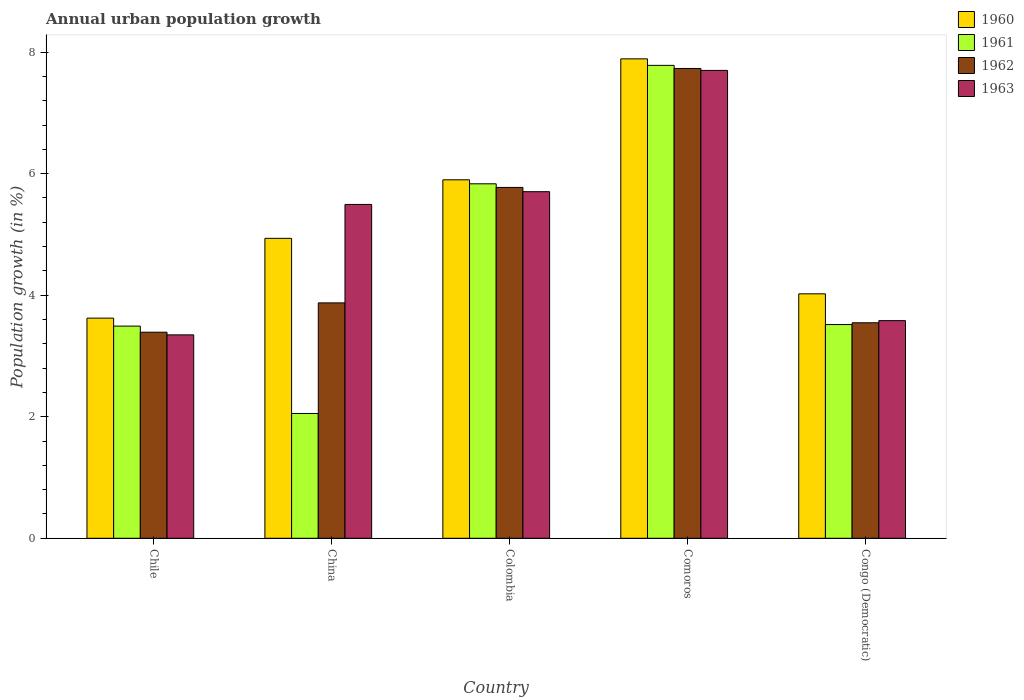How many different coloured bars are there?
Make the answer very short. 4. How many groups of bars are there?
Give a very brief answer. 5. How many bars are there on the 4th tick from the left?
Make the answer very short. 4. What is the label of the 3rd group of bars from the left?
Keep it short and to the point. Colombia. What is the percentage of urban population growth in 1963 in Comoros?
Provide a succinct answer. 7.7. Across all countries, what is the maximum percentage of urban population growth in 1963?
Keep it short and to the point. 7.7. Across all countries, what is the minimum percentage of urban population growth in 1962?
Your response must be concise. 3.39. In which country was the percentage of urban population growth in 1963 maximum?
Give a very brief answer. Comoros. In which country was the percentage of urban population growth in 1963 minimum?
Your answer should be compact. Chile. What is the total percentage of urban population growth in 1960 in the graph?
Keep it short and to the point. 26.37. What is the difference between the percentage of urban population growth in 1962 in Chile and that in China?
Keep it short and to the point. -0.48. What is the difference between the percentage of urban population growth in 1960 in Colombia and the percentage of urban population growth in 1963 in Comoros?
Your answer should be compact. -1.8. What is the average percentage of urban population growth in 1963 per country?
Offer a terse response. 5.17. What is the difference between the percentage of urban population growth of/in 1961 and percentage of urban population growth of/in 1962 in China?
Your answer should be compact. -1.82. In how many countries, is the percentage of urban population growth in 1962 greater than 1.2000000000000002 %?
Provide a succinct answer. 5. What is the ratio of the percentage of urban population growth in 1960 in China to that in Comoros?
Your answer should be very brief. 0.63. What is the difference between the highest and the second highest percentage of urban population growth in 1962?
Your answer should be compact. -1.9. What is the difference between the highest and the lowest percentage of urban population growth in 1963?
Offer a terse response. 4.35. Is it the case that in every country, the sum of the percentage of urban population growth in 1960 and percentage of urban population growth in 1963 is greater than the sum of percentage of urban population growth in 1961 and percentage of urban population growth in 1962?
Give a very brief answer. No. What does the 1st bar from the left in Colombia represents?
Make the answer very short. 1960. Is it the case that in every country, the sum of the percentage of urban population growth in 1960 and percentage of urban population growth in 1962 is greater than the percentage of urban population growth in 1961?
Make the answer very short. Yes. Are all the bars in the graph horizontal?
Ensure brevity in your answer.  No. How many countries are there in the graph?
Your answer should be compact. 5. Does the graph contain any zero values?
Offer a terse response. No. How are the legend labels stacked?
Make the answer very short. Vertical. What is the title of the graph?
Provide a succinct answer. Annual urban population growth. What is the label or title of the Y-axis?
Your answer should be very brief. Population growth (in %). What is the Population growth (in %) in 1960 in Chile?
Your answer should be very brief. 3.62. What is the Population growth (in %) in 1961 in Chile?
Provide a short and direct response. 3.49. What is the Population growth (in %) of 1962 in Chile?
Make the answer very short. 3.39. What is the Population growth (in %) in 1963 in Chile?
Your answer should be compact. 3.35. What is the Population growth (in %) in 1960 in China?
Your answer should be compact. 4.94. What is the Population growth (in %) of 1961 in China?
Your answer should be very brief. 2.05. What is the Population growth (in %) of 1962 in China?
Your response must be concise. 3.87. What is the Population growth (in %) of 1963 in China?
Your response must be concise. 5.49. What is the Population growth (in %) in 1960 in Colombia?
Your answer should be very brief. 5.9. What is the Population growth (in %) in 1961 in Colombia?
Make the answer very short. 5.83. What is the Population growth (in %) in 1962 in Colombia?
Provide a short and direct response. 5.77. What is the Population growth (in %) in 1963 in Colombia?
Provide a succinct answer. 5.7. What is the Population growth (in %) of 1960 in Comoros?
Provide a short and direct response. 7.89. What is the Population growth (in %) in 1961 in Comoros?
Keep it short and to the point. 7.78. What is the Population growth (in %) of 1962 in Comoros?
Make the answer very short. 7.73. What is the Population growth (in %) in 1963 in Comoros?
Offer a terse response. 7.7. What is the Population growth (in %) of 1960 in Congo (Democratic)?
Ensure brevity in your answer.  4.02. What is the Population growth (in %) in 1961 in Congo (Democratic)?
Make the answer very short. 3.52. What is the Population growth (in %) in 1962 in Congo (Democratic)?
Your response must be concise. 3.55. What is the Population growth (in %) in 1963 in Congo (Democratic)?
Make the answer very short. 3.58. Across all countries, what is the maximum Population growth (in %) in 1960?
Make the answer very short. 7.89. Across all countries, what is the maximum Population growth (in %) of 1961?
Your answer should be very brief. 7.78. Across all countries, what is the maximum Population growth (in %) of 1962?
Provide a short and direct response. 7.73. Across all countries, what is the maximum Population growth (in %) of 1963?
Your answer should be very brief. 7.7. Across all countries, what is the minimum Population growth (in %) in 1960?
Your response must be concise. 3.62. Across all countries, what is the minimum Population growth (in %) of 1961?
Provide a succinct answer. 2.05. Across all countries, what is the minimum Population growth (in %) in 1962?
Provide a succinct answer. 3.39. Across all countries, what is the minimum Population growth (in %) in 1963?
Make the answer very short. 3.35. What is the total Population growth (in %) in 1960 in the graph?
Provide a succinct answer. 26.37. What is the total Population growth (in %) of 1961 in the graph?
Give a very brief answer. 22.68. What is the total Population growth (in %) in 1962 in the graph?
Offer a terse response. 24.32. What is the total Population growth (in %) in 1963 in the graph?
Offer a very short reply. 25.82. What is the difference between the Population growth (in %) in 1960 in Chile and that in China?
Keep it short and to the point. -1.31. What is the difference between the Population growth (in %) of 1961 in Chile and that in China?
Offer a terse response. 1.44. What is the difference between the Population growth (in %) in 1962 in Chile and that in China?
Your answer should be very brief. -0.48. What is the difference between the Population growth (in %) of 1963 in Chile and that in China?
Provide a short and direct response. -2.15. What is the difference between the Population growth (in %) in 1960 in Chile and that in Colombia?
Give a very brief answer. -2.28. What is the difference between the Population growth (in %) in 1961 in Chile and that in Colombia?
Ensure brevity in your answer.  -2.34. What is the difference between the Population growth (in %) of 1962 in Chile and that in Colombia?
Offer a very short reply. -2.38. What is the difference between the Population growth (in %) in 1963 in Chile and that in Colombia?
Your answer should be very brief. -2.36. What is the difference between the Population growth (in %) of 1960 in Chile and that in Comoros?
Your response must be concise. -4.27. What is the difference between the Population growth (in %) in 1961 in Chile and that in Comoros?
Your answer should be compact. -4.29. What is the difference between the Population growth (in %) of 1962 in Chile and that in Comoros?
Provide a short and direct response. -4.34. What is the difference between the Population growth (in %) in 1963 in Chile and that in Comoros?
Your response must be concise. -4.35. What is the difference between the Population growth (in %) in 1960 in Chile and that in Congo (Democratic)?
Your answer should be compact. -0.4. What is the difference between the Population growth (in %) of 1961 in Chile and that in Congo (Democratic)?
Give a very brief answer. -0.03. What is the difference between the Population growth (in %) of 1962 in Chile and that in Congo (Democratic)?
Your answer should be compact. -0.16. What is the difference between the Population growth (in %) of 1963 in Chile and that in Congo (Democratic)?
Your answer should be compact. -0.23. What is the difference between the Population growth (in %) in 1960 in China and that in Colombia?
Your answer should be very brief. -0.96. What is the difference between the Population growth (in %) of 1961 in China and that in Colombia?
Provide a succinct answer. -3.78. What is the difference between the Population growth (in %) of 1962 in China and that in Colombia?
Your answer should be compact. -1.9. What is the difference between the Population growth (in %) of 1963 in China and that in Colombia?
Make the answer very short. -0.21. What is the difference between the Population growth (in %) in 1960 in China and that in Comoros?
Ensure brevity in your answer.  -2.95. What is the difference between the Population growth (in %) in 1961 in China and that in Comoros?
Your response must be concise. -5.73. What is the difference between the Population growth (in %) in 1962 in China and that in Comoros?
Your response must be concise. -3.86. What is the difference between the Population growth (in %) of 1963 in China and that in Comoros?
Offer a terse response. -2.21. What is the difference between the Population growth (in %) of 1960 in China and that in Congo (Democratic)?
Provide a succinct answer. 0.91. What is the difference between the Population growth (in %) in 1961 in China and that in Congo (Democratic)?
Make the answer very short. -1.46. What is the difference between the Population growth (in %) in 1962 in China and that in Congo (Democratic)?
Offer a terse response. 0.33. What is the difference between the Population growth (in %) of 1963 in China and that in Congo (Democratic)?
Keep it short and to the point. 1.91. What is the difference between the Population growth (in %) in 1960 in Colombia and that in Comoros?
Offer a terse response. -1.99. What is the difference between the Population growth (in %) in 1961 in Colombia and that in Comoros?
Offer a very short reply. -1.95. What is the difference between the Population growth (in %) of 1962 in Colombia and that in Comoros?
Make the answer very short. -1.96. What is the difference between the Population growth (in %) of 1963 in Colombia and that in Comoros?
Make the answer very short. -2. What is the difference between the Population growth (in %) in 1960 in Colombia and that in Congo (Democratic)?
Keep it short and to the point. 1.88. What is the difference between the Population growth (in %) in 1961 in Colombia and that in Congo (Democratic)?
Provide a short and direct response. 2.32. What is the difference between the Population growth (in %) of 1962 in Colombia and that in Congo (Democratic)?
Offer a terse response. 2.23. What is the difference between the Population growth (in %) of 1963 in Colombia and that in Congo (Democratic)?
Make the answer very short. 2.12. What is the difference between the Population growth (in %) in 1960 in Comoros and that in Congo (Democratic)?
Offer a very short reply. 3.87. What is the difference between the Population growth (in %) in 1961 in Comoros and that in Congo (Democratic)?
Your answer should be compact. 4.26. What is the difference between the Population growth (in %) in 1962 in Comoros and that in Congo (Democratic)?
Make the answer very short. 4.18. What is the difference between the Population growth (in %) in 1963 in Comoros and that in Congo (Democratic)?
Provide a succinct answer. 4.12. What is the difference between the Population growth (in %) in 1960 in Chile and the Population growth (in %) in 1961 in China?
Ensure brevity in your answer.  1.57. What is the difference between the Population growth (in %) in 1960 in Chile and the Population growth (in %) in 1962 in China?
Your response must be concise. -0.25. What is the difference between the Population growth (in %) of 1960 in Chile and the Population growth (in %) of 1963 in China?
Offer a very short reply. -1.87. What is the difference between the Population growth (in %) in 1961 in Chile and the Population growth (in %) in 1962 in China?
Make the answer very short. -0.38. What is the difference between the Population growth (in %) of 1961 in Chile and the Population growth (in %) of 1963 in China?
Provide a short and direct response. -2. What is the difference between the Population growth (in %) of 1962 in Chile and the Population growth (in %) of 1963 in China?
Offer a terse response. -2.1. What is the difference between the Population growth (in %) in 1960 in Chile and the Population growth (in %) in 1961 in Colombia?
Ensure brevity in your answer.  -2.21. What is the difference between the Population growth (in %) of 1960 in Chile and the Population growth (in %) of 1962 in Colombia?
Your answer should be very brief. -2.15. What is the difference between the Population growth (in %) of 1960 in Chile and the Population growth (in %) of 1963 in Colombia?
Give a very brief answer. -2.08. What is the difference between the Population growth (in %) in 1961 in Chile and the Population growth (in %) in 1962 in Colombia?
Make the answer very short. -2.28. What is the difference between the Population growth (in %) in 1961 in Chile and the Population growth (in %) in 1963 in Colombia?
Ensure brevity in your answer.  -2.21. What is the difference between the Population growth (in %) in 1962 in Chile and the Population growth (in %) in 1963 in Colombia?
Your answer should be compact. -2.31. What is the difference between the Population growth (in %) in 1960 in Chile and the Population growth (in %) in 1961 in Comoros?
Provide a short and direct response. -4.16. What is the difference between the Population growth (in %) of 1960 in Chile and the Population growth (in %) of 1962 in Comoros?
Offer a very short reply. -4.11. What is the difference between the Population growth (in %) in 1960 in Chile and the Population growth (in %) in 1963 in Comoros?
Give a very brief answer. -4.08. What is the difference between the Population growth (in %) of 1961 in Chile and the Population growth (in %) of 1962 in Comoros?
Offer a terse response. -4.24. What is the difference between the Population growth (in %) in 1961 in Chile and the Population growth (in %) in 1963 in Comoros?
Keep it short and to the point. -4.21. What is the difference between the Population growth (in %) of 1962 in Chile and the Population growth (in %) of 1963 in Comoros?
Your response must be concise. -4.31. What is the difference between the Population growth (in %) of 1960 in Chile and the Population growth (in %) of 1961 in Congo (Democratic)?
Your response must be concise. 0.11. What is the difference between the Population growth (in %) in 1960 in Chile and the Population growth (in %) in 1962 in Congo (Democratic)?
Offer a very short reply. 0.08. What is the difference between the Population growth (in %) of 1960 in Chile and the Population growth (in %) of 1963 in Congo (Democratic)?
Ensure brevity in your answer.  0.04. What is the difference between the Population growth (in %) in 1961 in Chile and the Population growth (in %) in 1962 in Congo (Democratic)?
Keep it short and to the point. -0.05. What is the difference between the Population growth (in %) of 1961 in Chile and the Population growth (in %) of 1963 in Congo (Democratic)?
Keep it short and to the point. -0.09. What is the difference between the Population growth (in %) of 1962 in Chile and the Population growth (in %) of 1963 in Congo (Democratic)?
Provide a succinct answer. -0.19. What is the difference between the Population growth (in %) of 1960 in China and the Population growth (in %) of 1961 in Colombia?
Give a very brief answer. -0.9. What is the difference between the Population growth (in %) in 1960 in China and the Population growth (in %) in 1962 in Colombia?
Offer a terse response. -0.84. What is the difference between the Population growth (in %) of 1960 in China and the Population growth (in %) of 1963 in Colombia?
Make the answer very short. -0.77. What is the difference between the Population growth (in %) in 1961 in China and the Population growth (in %) in 1962 in Colombia?
Offer a terse response. -3.72. What is the difference between the Population growth (in %) of 1961 in China and the Population growth (in %) of 1963 in Colombia?
Ensure brevity in your answer.  -3.65. What is the difference between the Population growth (in %) in 1962 in China and the Population growth (in %) in 1963 in Colombia?
Provide a short and direct response. -1.83. What is the difference between the Population growth (in %) of 1960 in China and the Population growth (in %) of 1961 in Comoros?
Keep it short and to the point. -2.85. What is the difference between the Population growth (in %) of 1960 in China and the Population growth (in %) of 1962 in Comoros?
Keep it short and to the point. -2.8. What is the difference between the Population growth (in %) of 1960 in China and the Population growth (in %) of 1963 in Comoros?
Ensure brevity in your answer.  -2.76. What is the difference between the Population growth (in %) of 1961 in China and the Population growth (in %) of 1962 in Comoros?
Your response must be concise. -5.68. What is the difference between the Population growth (in %) of 1961 in China and the Population growth (in %) of 1963 in Comoros?
Offer a very short reply. -5.65. What is the difference between the Population growth (in %) of 1962 in China and the Population growth (in %) of 1963 in Comoros?
Give a very brief answer. -3.83. What is the difference between the Population growth (in %) of 1960 in China and the Population growth (in %) of 1961 in Congo (Democratic)?
Your response must be concise. 1.42. What is the difference between the Population growth (in %) of 1960 in China and the Population growth (in %) of 1962 in Congo (Democratic)?
Make the answer very short. 1.39. What is the difference between the Population growth (in %) in 1960 in China and the Population growth (in %) in 1963 in Congo (Democratic)?
Offer a terse response. 1.35. What is the difference between the Population growth (in %) in 1961 in China and the Population growth (in %) in 1962 in Congo (Democratic)?
Give a very brief answer. -1.49. What is the difference between the Population growth (in %) of 1961 in China and the Population growth (in %) of 1963 in Congo (Democratic)?
Offer a terse response. -1.53. What is the difference between the Population growth (in %) of 1962 in China and the Population growth (in %) of 1963 in Congo (Democratic)?
Give a very brief answer. 0.29. What is the difference between the Population growth (in %) in 1960 in Colombia and the Population growth (in %) in 1961 in Comoros?
Keep it short and to the point. -1.88. What is the difference between the Population growth (in %) in 1960 in Colombia and the Population growth (in %) in 1962 in Comoros?
Provide a succinct answer. -1.83. What is the difference between the Population growth (in %) in 1960 in Colombia and the Population growth (in %) in 1963 in Comoros?
Provide a short and direct response. -1.8. What is the difference between the Population growth (in %) of 1961 in Colombia and the Population growth (in %) of 1962 in Comoros?
Ensure brevity in your answer.  -1.9. What is the difference between the Population growth (in %) in 1961 in Colombia and the Population growth (in %) in 1963 in Comoros?
Make the answer very short. -1.87. What is the difference between the Population growth (in %) of 1962 in Colombia and the Population growth (in %) of 1963 in Comoros?
Your answer should be very brief. -1.93. What is the difference between the Population growth (in %) of 1960 in Colombia and the Population growth (in %) of 1961 in Congo (Democratic)?
Provide a succinct answer. 2.38. What is the difference between the Population growth (in %) of 1960 in Colombia and the Population growth (in %) of 1962 in Congo (Democratic)?
Ensure brevity in your answer.  2.35. What is the difference between the Population growth (in %) in 1960 in Colombia and the Population growth (in %) in 1963 in Congo (Democratic)?
Provide a short and direct response. 2.32. What is the difference between the Population growth (in %) in 1961 in Colombia and the Population growth (in %) in 1962 in Congo (Democratic)?
Ensure brevity in your answer.  2.29. What is the difference between the Population growth (in %) in 1961 in Colombia and the Population growth (in %) in 1963 in Congo (Democratic)?
Your answer should be very brief. 2.25. What is the difference between the Population growth (in %) of 1962 in Colombia and the Population growth (in %) of 1963 in Congo (Democratic)?
Your answer should be compact. 2.19. What is the difference between the Population growth (in %) of 1960 in Comoros and the Population growth (in %) of 1961 in Congo (Democratic)?
Your response must be concise. 4.37. What is the difference between the Population growth (in %) of 1960 in Comoros and the Population growth (in %) of 1962 in Congo (Democratic)?
Offer a very short reply. 4.34. What is the difference between the Population growth (in %) in 1960 in Comoros and the Population growth (in %) in 1963 in Congo (Democratic)?
Provide a succinct answer. 4.31. What is the difference between the Population growth (in %) of 1961 in Comoros and the Population growth (in %) of 1962 in Congo (Democratic)?
Offer a terse response. 4.24. What is the difference between the Population growth (in %) in 1961 in Comoros and the Population growth (in %) in 1963 in Congo (Democratic)?
Your answer should be compact. 4.2. What is the difference between the Population growth (in %) of 1962 in Comoros and the Population growth (in %) of 1963 in Congo (Democratic)?
Ensure brevity in your answer.  4.15. What is the average Population growth (in %) of 1960 per country?
Your answer should be very brief. 5.27. What is the average Population growth (in %) in 1961 per country?
Make the answer very short. 4.54. What is the average Population growth (in %) of 1962 per country?
Keep it short and to the point. 4.86. What is the average Population growth (in %) in 1963 per country?
Give a very brief answer. 5.17. What is the difference between the Population growth (in %) in 1960 and Population growth (in %) in 1961 in Chile?
Provide a succinct answer. 0.13. What is the difference between the Population growth (in %) of 1960 and Population growth (in %) of 1962 in Chile?
Offer a terse response. 0.23. What is the difference between the Population growth (in %) in 1960 and Population growth (in %) in 1963 in Chile?
Offer a terse response. 0.28. What is the difference between the Population growth (in %) in 1961 and Population growth (in %) in 1962 in Chile?
Give a very brief answer. 0.1. What is the difference between the Population growth (in %) of 1961 and Population growth (in %) of 1963 in Chile?
Give a very brief answer. 0.14. What is the difference between the Population growth (in %) of 1962 and Population growth (in %) of 1963 in Chile?
Your answer should be very brief. 0.04. What is the difference between the Population growth (in %) of 1960 and Population growth (in %) of 1961 in China?
Make the answer very short. 2.88. What is the difference between the Population growth (in %) of 1960 and Population growth (in %) of 1962 in China?
Offer a terse response. 1.06. What is the difference between the Population growth (in %) in 1960 and Population growth (in %) in 1963 in China?
Provide a short and direct response. -0.56. What is the difference between the Population growth (in %) in 1961 and Population growth (in %) in 1962 in China?
Ensure brevity in your answer.  -1.82. What is the difference between the Population growth (in %) of 1961 and Population growth (in %) of 1963 in China?
Make the answer very short. -3.44. What is the difference between the Population growth (in %) of 1962 and Population growth (in %) of 1963 in China?
Keep it short and to the point. -1.62. What is the difference between the Population growth (in %) in 1960 and Population growth (in %) in 1961 in Colombia?
Ensure brevity in your answer.  0.07. What is the difference between the Population growth (in %) in 1960 and Population growth (in %) in 1962 in Colombia?
Give a very brief answer. 0.13. What is the difference between the Population growth (in %) in 1960 and Population growth (in %) in 1963 in Colombia?
Ensure brevity in your answer.  0.2. What is the difference between the Population growth (in %) of 1961 and Population growth (in %) of 1962 in Colombia?
Provide a short and direct response. 0.06. What is the difference between the Population growth (in %) of 1961 and Population growth (in %) of 1963 in Colombia?
Provide a succinct answer. 0.13. What is the difference between the Population growth (in %) of 1962 and Population growth (in %) of 1963 in Colombia?
Ensure brevity in your answer.  0.07. What is the difference between the Population growth (in %) of 1960 and Population growth (in %) of 1961 in Comoros?
Make the answer very short. 0.11. What is the difference between the Population growth (in %) of 1960 and Population growth (in %) of 1962 in Comoros?
Your response must be concise. 0.16. What is the difference between the Population growth (in %) in 1960 and Population growth (in %) in 1963 in Comoros?
Provide a succinct answer. 0.19. What is the difference between the Population growth (in %) in 1961 and Population growth (in %) in 1962 in Comoros?
Your answer should be compact. 0.05. What is the difference between the Population growth (in %) in 1961 and Population growth (in %) in 1963 in Comoros?
Offer a very short reply. 0.08. What is the difference between the Population growth (in %) in 1962 and Population growth (in %) in 1963 in Comoros?
Ensure brevity in your answer.  0.03. What is the difference between the Population growth (in %) in 1960 and Population growth (in %) in 1961 in Congo (Democratic)?
Your answer should be compact. 0.51. What is the difference between the Population growth (in %) of 1960 and Population growth (in %) of 1962 in Congo (Democratic)?
Your response must be concise. 0.48. What is the difference between the Population growth (in %) of 1960 and Population growth (in %) of 1963 in Congo (Democratic)?
Your response must be concise. 0.44. What is the difference between the Population growth (in %) in 1961 and Population growth (in %) in 1962 in Congo (Democratic)?
Give a very brief answer. -0.03. What is the difference between the Population growth (in %) in 1961 and Population growth (in %) in 1963 in Congo (Democratic)?
Provide a succinct answer. -0.06. What is the difference between the Population growth (in %) of 1962 and Population growth (in %) of 1963 in Congo (Democratic)?
Your answer should be compact. -0.04. What is the ratio of the Population growth (in %) in 1960 in Chile to that in China?
Ensure brevity in your answer.  0.73. What is the ratio of the Population growth (in %) of 1961 in Chile to that in China?
Give a very brief answer. 1.7. What is the ratio of the Population growth (in %) of 1962 in Chile to that in China?
Provide a short and direct response. 0.88. What is the ratio of the Population growth (in %) in 1963 in Chile to that in China?
Your answer should be very brief. 0.61. What is the ratio of the Population growth (in %) in 1960 in Chile to that in Colombia?
Give a very brief answer. 0.61. What is the ratio of the Population growth (in %) of 1961 in Chile to that in Colombia?
Ensure brevity in your answer.  0.6. What is the ratio of the Population growth (in %) in 1962 in Chile to that in Colombia?
Offer a terse response. 0.59. What is the ratio of the Population growth (in %) in 1963 in Chile to that in Colombia?
Provide a succinct answer. 0.59. What is the ratio of the Population growth (in %) in 1960 in Chile to that in Comoros?
Provide a short and direct response. 0.46. What is the ratio of the Population growth (in %) of 1961 in Chile to that in Comoros?
Your response must be concise. 0.45. What is the ratio of the Population growth (in %) of 1962 in Chile to that in Comoros?
Offer a very short reply. 0.44. What is the ratio of the Population growth (in %) of 1963 in Chile to that in Comoros?
Ensure brevity in your answer.  0.43. What is the ratio of the Population growth (in %) in 1960 in Chile to that in Congo (Democratic)?
Your answer should be very brief. 0.9. What is the ratio of the Population growth (in %) in 1961 in Chile to that in Congo (Democratic)?
Give a very brief answer. 0.99. What is the ratio of the Population growth (in %) in 1962 in Chile to that in Congo (Democratic)?
Your response must be concise. 0.96. What is the ratio of the Population growth (in %) of 1963 in Chile to that in Congo (Democratic)?
Make the answer very short. 0.93. What is the ratio of the Population growth (in %) of 1960 in China to that in Colombia?
Offer a very short reply. 0.84. What is the ratio of the Population growth (in %) of 1961 in China to that in Colombia?
Provide a succinct answer. 0.35. What is the ratio of the Population growth (in %) in 1962 in China to that in Colombia?
Keep it short and to the point. 0.67. What is the ratio of the Population growth (in %) in 1963 in China to that in Colombia?
Your answer should be compact. 0.96. What is the ratio of the Population growth (in %) in 1960 in China to that in Comoros?
Your answer should be very brief. 0.63. What is the ratio of the Population growth (in %) of 1961 in China to that in Comoros?
Keep it short and to the point. 0.26. What is the ratio of the Population growth (in %) of 1962 in China to that in Comoros?
Provide a succinct answer. 0.5. What is the ratio of the Population growth (in %) in 1963 in China to that in Comoros?
Offer a terse response. 0.71. What is the ratio of the Population growth (in %) in 1960 in China to that in Congo (Democratic)?
Ensure brevity in your answer.  1.23. What is the ratio of the Population growth (in %) in 1961 in China to that in Congo (Democratic)?
Provide a succinct answer. 0.58. What is the ratio of the Population growth (in %) of 1962 in China to that in Congo (Democratic)?
Your answer should be very brief. 1.09. What is the ratio of the Population growth (in %) in 1963 in China to that in Congo (Democratic)?
Make the answer very short. 1.53. What is the ratio of the Population growth (in %) in 1960 in Colombia to that in Comoros?
Make the answer very short. 0.75. What is the ratio of the Population growth (in %) of 1961 in Colombia to that in Comoros?
Keep it short and to the point. 0.75. What is the ratio of the Population growth (in %) in 1962 in Colombia to that in Comoros?
Make the answer very short. 0.75. What is the ratio of the Population growth (in %) of 1963 in Colombia to that in Comoros?
Give a very brief answer. 0.74. What is the ratio of the Population growth (in %) in 1960 in Colombia to that in Congo (Democratic)?
Ensure brevity in your answer.  1.47. What is the ratio of the Population growth (in %) in 1961 in Colombia to that in Congo (Democratic)?
Keep it short and to the point. 1.66. What is the ratio of the Population growth (in %) of 1962 in Colombia to that in Congo (Democratic)?
Offer a terse response. 1.63. What is the ratio of the Population growth (in %) of 1963 in Colombia to that in Congo (Democratic)?
Offer a very short reply. 1.59. What is the ratio of the Population growth (in %) of 1960 in Comoros to that in Congo (Democratic)?
Offer a very short reply. 1.96. What is the ratio of the Population growth (in %) in 1961 in Comoros to that in Congo (Democratic)?
Keep it short and to the point. 2.21. What is the ratio of the Population growth (in %) in 1962 in Comoros to that in Congo (Democratic)?
Offer a very short reply. 2.18. What is the ratio of the Population growth (in %) of 1963 in Comoros to that in Congo (Democratic)?
Provide a short and direct response. 2.15. What is the difference between the highest and the second highest Population growth (in %) in 1960?
Keep it short and to the point. 1.99. What is the difference between the highest and the second highest Population growth (in %) of 1961?
Your answer should be very brief. 1.95. What is the difference between the highest and the second highest Population growth (in %) in 1962?
Provide a short and direct response. 1.96. What is the difference between the highest and the second highest Population growth (in %) in 1963?
Your answer should be very brief. 2. What is the difference between the highest and the lowest Population growth (in %) of 1960?
Your answer should be compact. 4.27. What is the difference between the highest and the lowest Population growth (in %) in 1961?
Make the answer very short. 5.73. What is the difference between the highest and the lowest Population growth (in %) in 1962?
Provide a short and direct response. 4.34. What is the difference between the highest and the lowest Population growth (in %) in 1963?
Your answer should be compact. 4.35. 